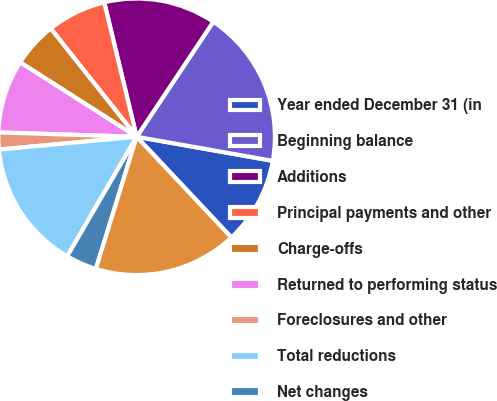<chart> <loc_0><loc_0><loc_500><loc_500><pie_chart><fcel>Year ended December 31 (in<fcel>Beginning balance<fcel>Additions<fcel>Principal payments and other<fcel>Charge-offs<fcel>Returned to performing status<fcel>Foreclosures and other<fcel>Total reductions<fcel>Net changes<fcel>Ending balance<nl><fcel>10.2%<fcel>18.43%<fcel>13.12%<fcel>6.91%<fcel>5.27%<fcel>8.55%<fcel>1.98%<fcel>15.14%<fcel>3.62%<fcel>16.78%<nl></chart> 